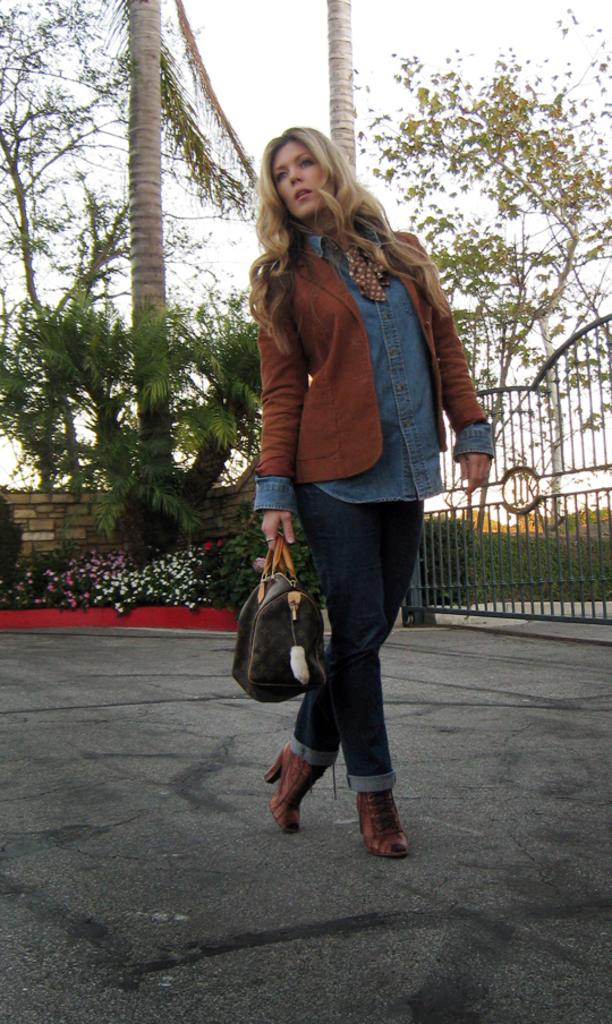What is the main subject of the image? There is a woman standing in the center of the image. What is the woman holding in the image? The woman is holding a bag. What can be seen in the background of the image? There are trees, the sky, plants, flowers, and a gate in the background of the image. What type of humor is the woman displaying in the image? There is no indication of humor in the image; it simply shows a woman standing and holding a bag. What color is the hat the woman is wearing in the image? The woman is not wearing a hat in the image. 